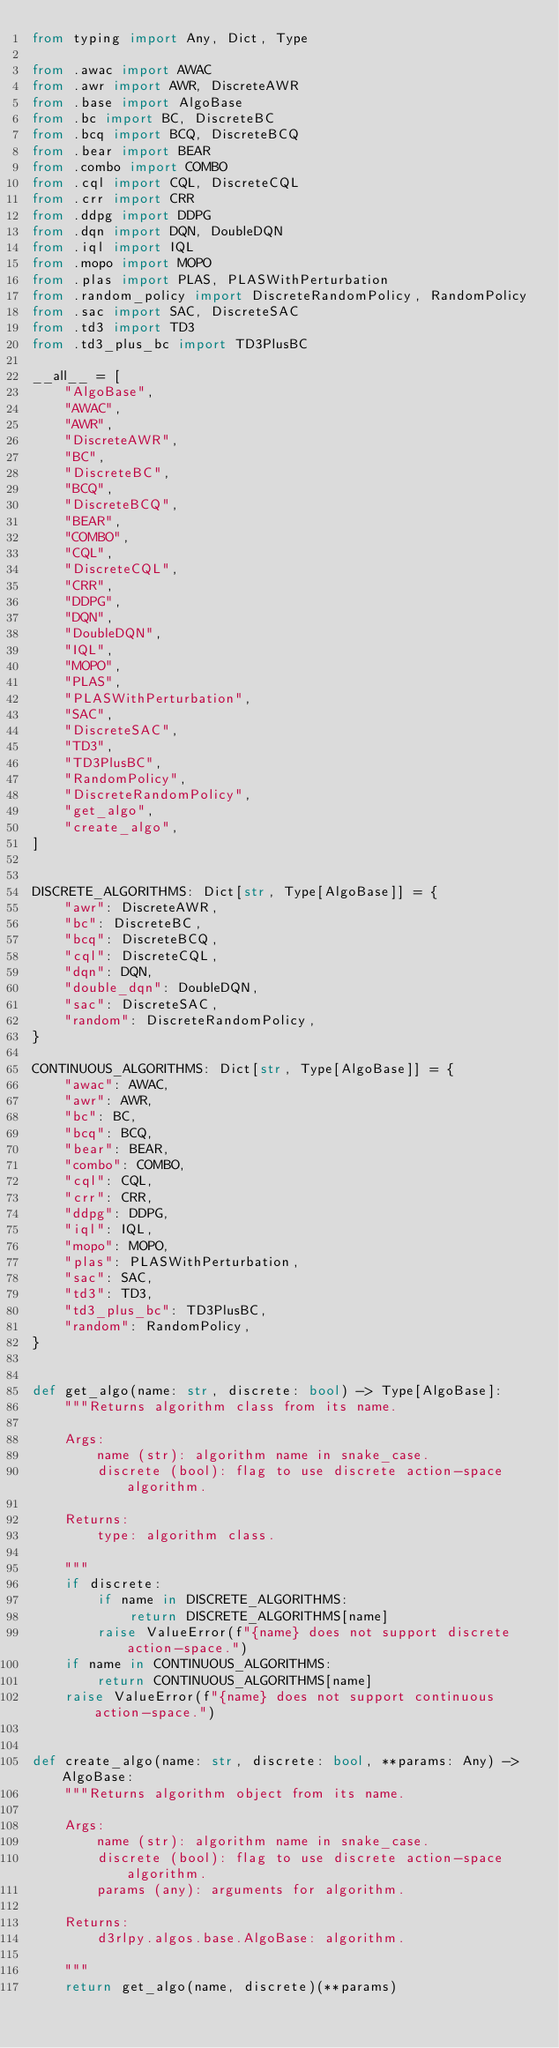<code> <loc_0><loc_0><loc_500><loc_500><_Python_>from typing import Any, Dict, Type

from .awac import AWAC
from .awr import AWR, DiscreteAWR
from .base import AlgoBase
from .bc import BC, DiscreteBC
from .bcq import BCQ, DiscreteBCQ
from .bear import BEAR
from .combo import COMBO
from .cql import CQL, DiscreteCQL
from .crr import CRR
from .ddpg import DDPG
from .dqn import DQN, DoubleDQN
from .iql import IQL
from .mopo import MOPO
from .plas import PLAS, PLASWithPerturbation
from .random_policy import DiscreteRandomPolicy, RandomPolicy
from .sac import SAC, DiscreteSAC
from .td3 import TD3
from .td3_plus_bc import TD3PlusBC

__all__ = [
    "AlgoBase",
    "AWAC",
    "AWR",
    "DiscreteAWR",
    "BC",
    "DiscreteBC",
    "BCQ",
    "DiscreteBCQ",
    "BEAR",
    "COMBO",
    "CQL",
    "DiscreteCQL",
    "CRR",
    "DDPG",
    "DQN",
    "DoubleDQN",
    "IQL",
    "MOPO",
    "PLAS",
    "PLASWithPerturbation",
    "SAC",
    "DiscreteSAC",
    "TD3",
    "TD3PlusBC",
    "RandomPolicy",
    "DiscreteRandomPolicy",
    "get_algo",
    "create_algo",
]


DISCRETE_ALGORITHMS: Dict[str, Type[AlgoBase]] = {
    "awr": DiscreteAWR,
    "bc": DiscreteBC,
    "bcq": DiscreteBCQ,
    "cql": DiscreteCQL,
    "dqn": DQN,
    "double_dqn": DoubleDQN,
    "sac": DiscreteSAC,
    "random": DiscreteRandomPolicy,
}

CONTINUOUS_ALGORITHMS: Dict[str, Type[AlgoBase]] = {
    "awac": AWAC,
    "awr": AWR,
    "bc": BC,
    "bcq": BCQ,
    "bear": BEAR,
    "combo": COMBO,
    "cql": CQL,
    "crr": CRR,
    "ddpg": DDPG,
    "iql": IQL,
    "mopo": MOPO,
    "plas": PLASWithPerturbation,
    "sac": SAC,
    "td3": TD3,
    "td3_plus_bc": TD3PlusBC,
    "random": RandomPolicy,
}


def get_algo(name: str, discrete: bool) -> Type[AlgoBase]:
    """Returns algorithm class from its name.

    Args:
        name (str): algorithm name in snake_case.
        discrete (bool): flag to use discrete action-space algorithm.

    Returns:
        type: algorithm class.

    """
    if discrete:
        if name in DISCRETE_ALGORITHMS:
            return DISCRETE_ALGORITHMS[name]
        raise ValueError(f"{name} does not support discrete action-space.")
    if name in CONTINUOUS_ALGORITHMS:
        return CONTINUOUS_ALGORITHMS[name]
    raise ValueError(f"{name} does not support continuous action-space.")


def create_algo(name: str, discrete: bool, **params: Any) -> AlgoBase:
    """Returns algorithm object from its name.

    Args:
        name (str): algorithm name in snake_case.
        discrete (bool): flag to use discrete action-space algorithm.
        params (any): arguments for algorithm.

    Returns:
        d3rlpy.algos.base.AlgoBase: algorithm.

    """
    return get_algo(name, discrete)(**params)
</code> 